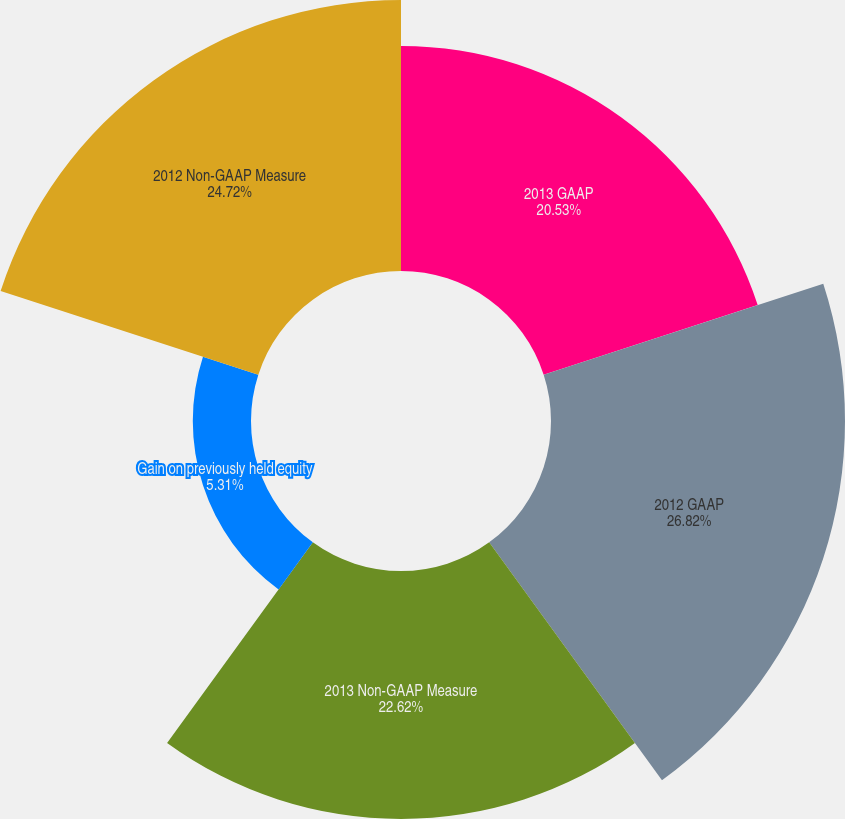<chart> <loc_0><loc_0><loc_500><loc_500><pie_chart><fcel>2013 GAAP<fcel>2012 GAAP<fcel>2013 Non-GAAP Measure<fcel>Gain on previously held equity<fcel>2012 Non-GAAP Measure<nl><fcel>20.53%<fcel>26.82%<fcel>22.62%<fcel>5.31%<fcel>24.72%<nl></chart> 